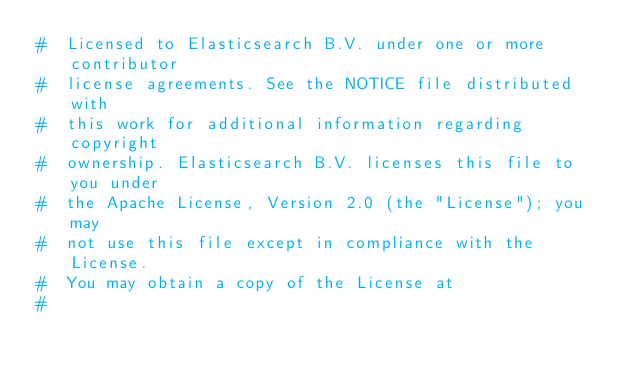Convert code to text. <code><loc_0><loc_0><loc_500><loc_500><_Python_>#  Licensed to Elasticsearch B.V. under one or more contributor
#  license agreements. See the NOTICE file distributed with
#  this work for additional information regarding copyright
#  ownership. Elasticsearch B.V. licenses this file to you under
#  the Apache License, Version 2.0 (the "License"); you may
#  not use this file except in compliance with the License.
#  You may obtain a copy of the License at
#</code> 